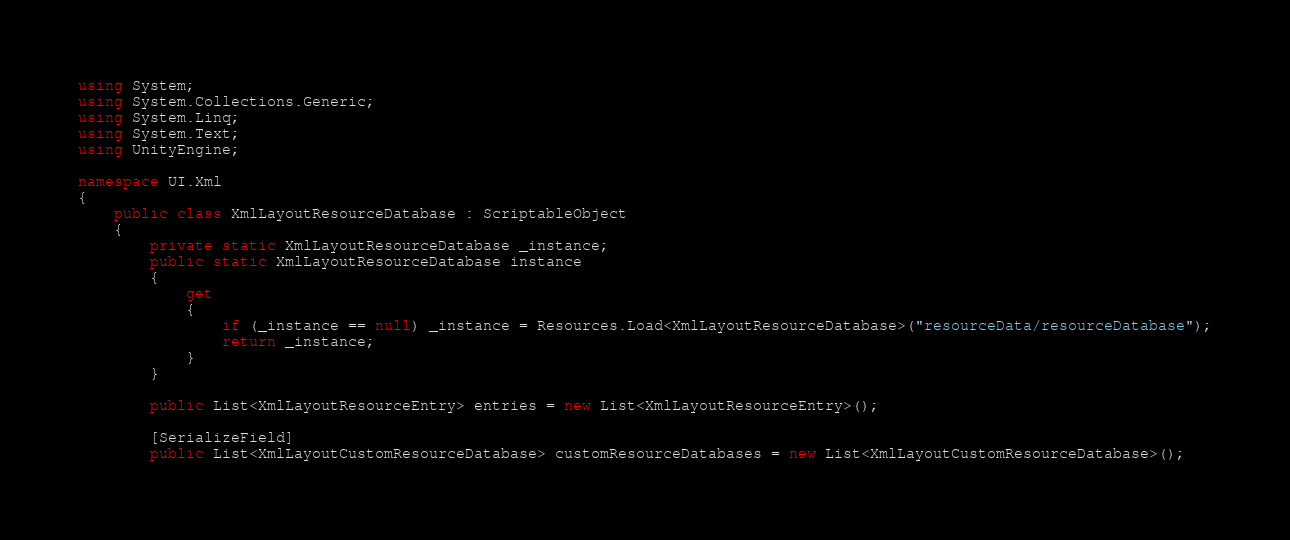<code> <loc_0><loc_0><loc_500><loc_500><_C#_>using System;
using System.Collections.Generic;
using System.Linq;
using System.Text;
using UnityEngine;

namespace UI.Xml
{    
    public class XmlLayoutResourceDatabase : ScriptableObject
    {
        private static XmlLayoutResourceDatabase _instance;
        public static XmlLayoutResourceDatabase instance
        {
            get
            {
                if (_instance == null) _instance = Resources.Load<XmlLayoutResourceDatabase>("resourceData/resourceDatabase");
                return _instance;
            }
        }

        public List<XmlLayoutResourceEntry> entries = new List<XmlLayoutResourceEntry>();

        [SerializeField]
        public List<XmlLayoutCustomResourceDatabase> customResourceDatabases = new List<XmlLayoutCustomResourceDatabase>();
</code> 